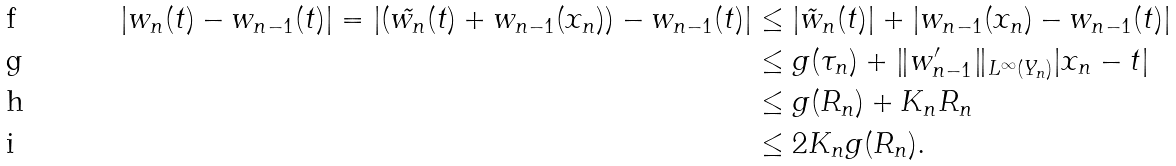Convert formula to latex. <formula><loc_0><loc_0><loc_500><loc_500>| w _ { n } ( t ) - w _ { n - 1 } ( t ) | = | ( \tilde { w _ { n } } ( t ) + w _ { n - 1 } ( x _ { n } ) ) - w _ { n - 1 } ( t ) | & \leq | \tilde { w } _ { n } ( t ) | + | w _ { n - 1 } ( x _ { n } ) - w _ { n - 1 } ( t ) | \\ & \leq g ( \tau _ { n } ) + \| w _ { n - 1 } ^ { \prime } \| _ { L ^ { \infty } ( Y _ { n } ) } | x _ { n } - t | \\ & \leq g ( R _ { n } ) + K _ { n } R _ { n } \\ & \leq 2 K _ { n } g ( R _ { n } ) .</formula> 